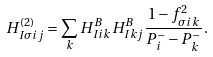Convert formula to latex. <formula><loc_0><loc_0><loc_500><loc_500>H _ { I \sigma i j } ^ { ( 2 ) } = \sum _ { k } H _ { I i k } ^ { B } H _ { I k j } ^ { B } \frac { 1 - f _ { \sigma i k } ^ { 2 } } { P _ { i } ^ { - } - P _ { k } ^ { - } } .</formula> 